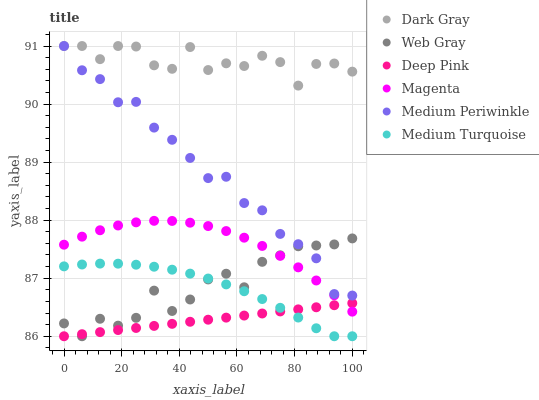Does Deep Pink have the minimum area under the curve?
Answer yes or no. Yes. Does Dark Gray have the maximum area under the curve?
Answer yes or no. Yes. Does Medium Periwinkle have the minimum area under the curve?
Answer yes or no. No. Does Medium Periwinkle have the maximum area under the curve?
Answer yes or no. No. Is Deep Pink the smoothest?
Answer yes or no. Yes. Is Dark Gray the roughest?
Answer yes or no. Yes. Is Medium Periwinkle the smoothest?
Answer yes or no. No. Is Medium Periwinkle the roughest?
Answer yes or no. No. Does Web Gray have the lowest value?
Answer yes or no. Yes. Does Medium Periwinkle have the lowest value?
Answer yes or no. No. Does Dark Gray have the highest value?
Answer yes or no. Yes. Does Deep Pink have the highest value?
Answer yes or no. No. Is Medium Turquoise less than Magenta?
Answer yes or no. Yes. Is Magenta greater than Medium Turquoise?
Answer yes or no. Yes. Does Medium Periwinkle intersect Dark Gray?
Answer yes or no. Yes. Is Medium Periwinkle less than Dark Gray?
Answer yes or no. No. Is Medium Periwinkle greater than Dark Gray?
Answer yes or no. No. Does Medium Turquoise intersect Magenta?
Answer yes or no. No. 